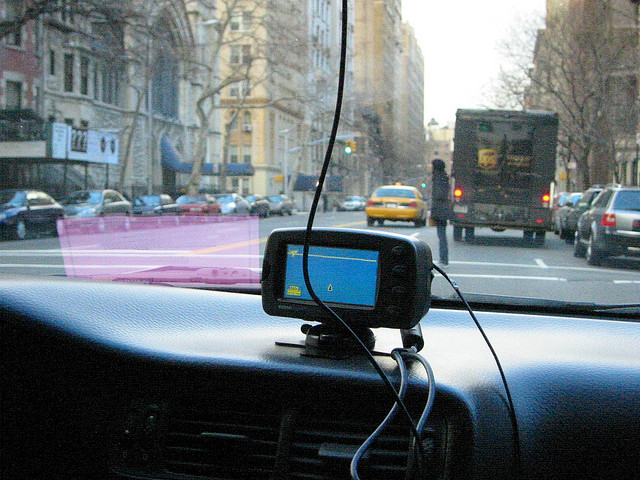<image>What GPS system is that? I am not sure what GPS system it is. It could be Garmin or Tomtom. What GPS system is that? I am not sure what GPS system is that. It can be 'garmin', 'tomtom' or 'magellan'. 